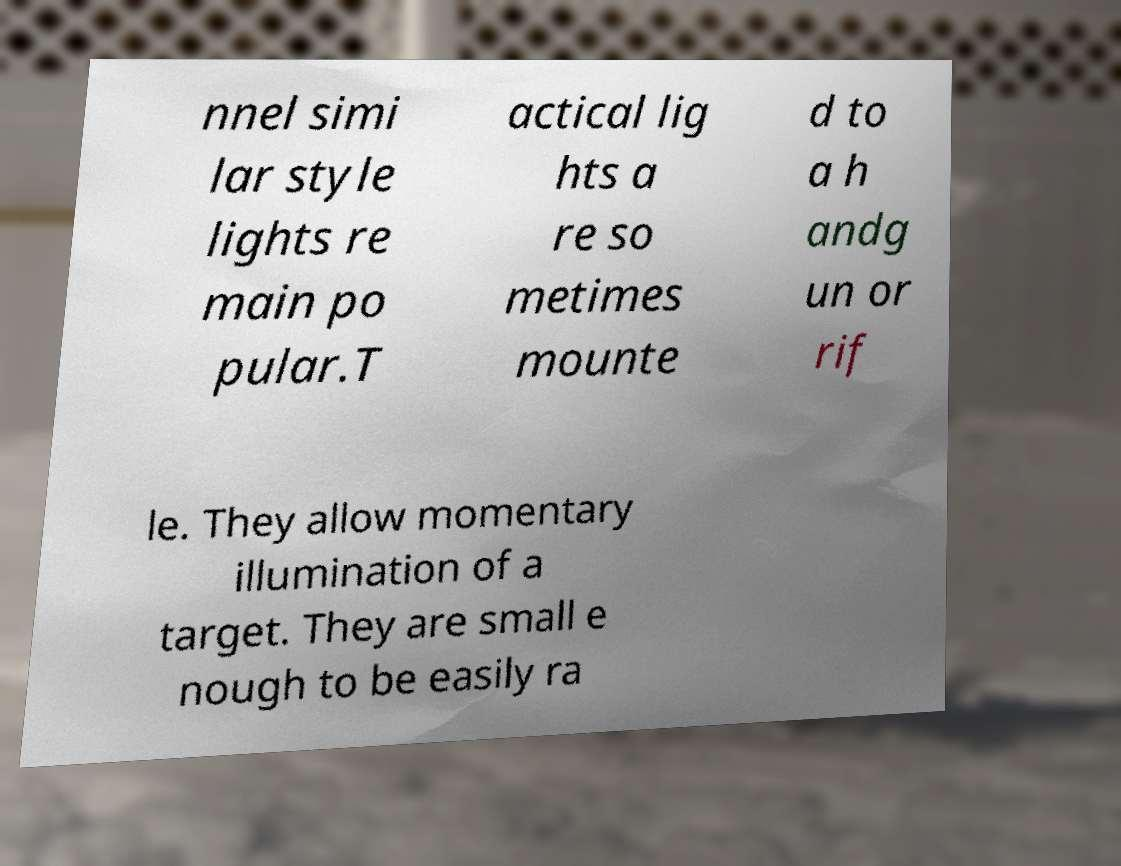What messages or text are displayed in this image? I need them in a readable, typed format. nnel simi lar style lights re main po pular.T actical lig hts a re so metimes mounte d to a h andg un or rif le. They allow momentary illumination of a target. They are small e nough to be easily ra 